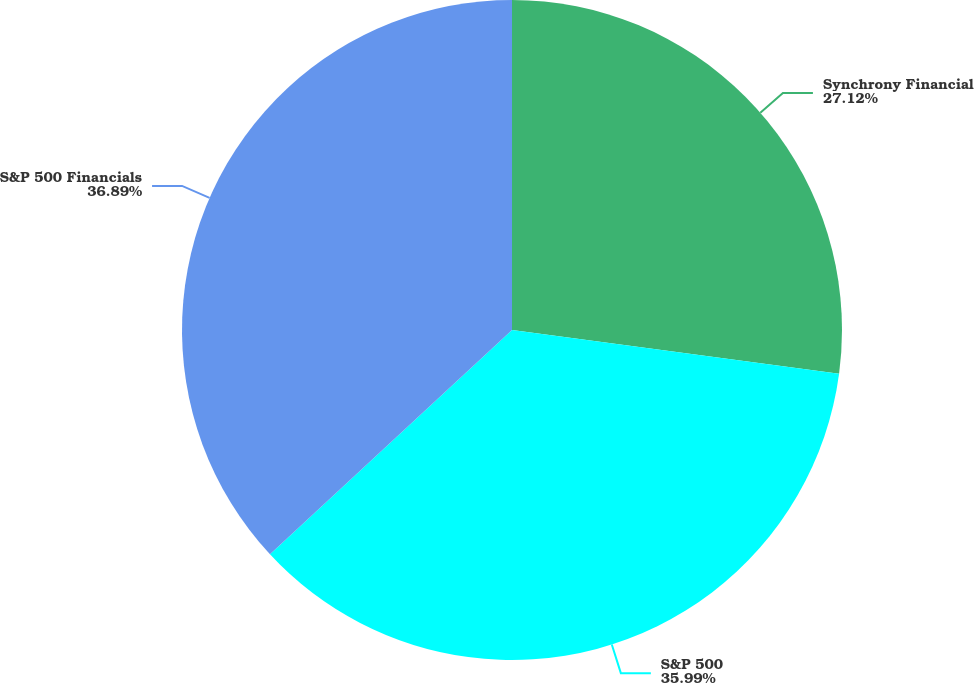Convert chart. <chart><loc_0><loc_0><loc_500><loc_500><pie_chart><fcel>Synchrony Financial<fcel>S&P 500<fcel>S&P 500 Financials<nl><fcel>27.12%<fcel>35.99%<fcel>36.9%<nl></chart> 